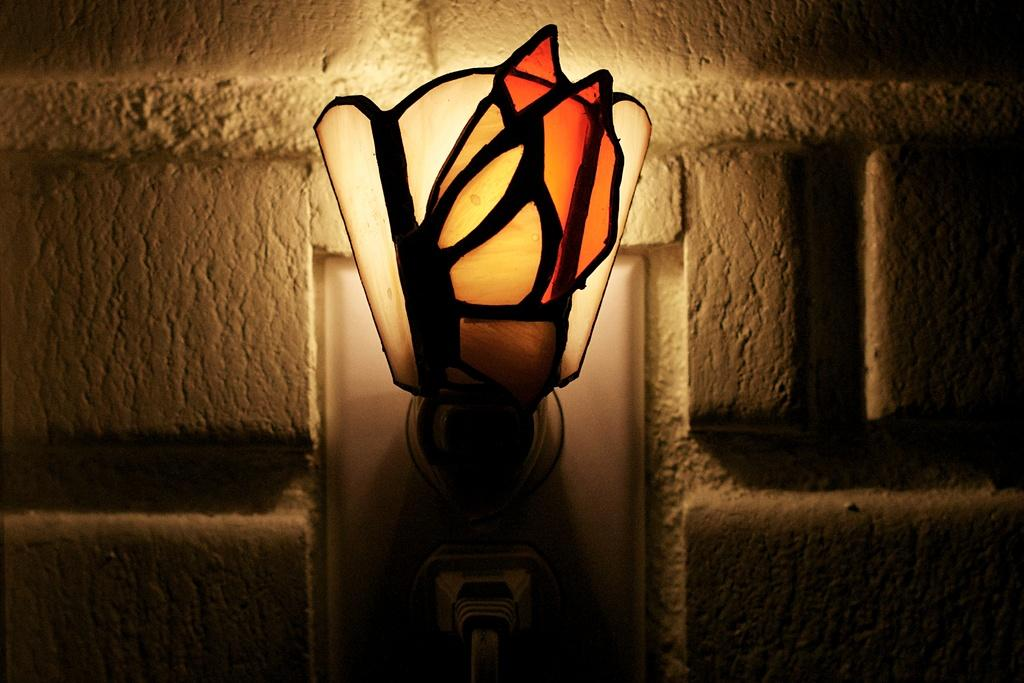What object can be seen in the image? There is a lamp in the image. Where is the lamp located in relation to the wall? The lamp is in the middle of a wall. What type of oil is used to light the lamp in the image? The image does not provide information about the type of oil used to light the lamp, nor does it show the lamp being lit. 